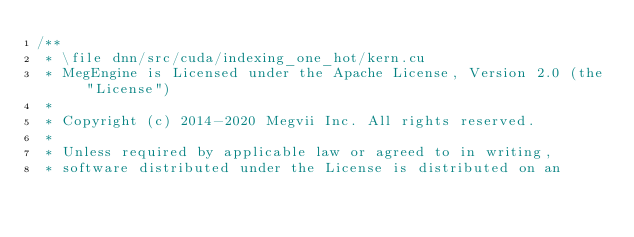<code> <loc_0><loc_0><loc_500><loc_500><_Cuda_>/**
 * \file dnn/src/cuda/indexing_one_hot/kern.cu
 * MegEngine is Licensed under the Apache License, Version 2.0 (the "License")
 *
 * Copyright (c) 2014-2020 Megvii Inc. All rights reserved.
 *
 * Unless required by applicable law or agreed to in writing,
 * software distributed under the License is distributed on an</code> 